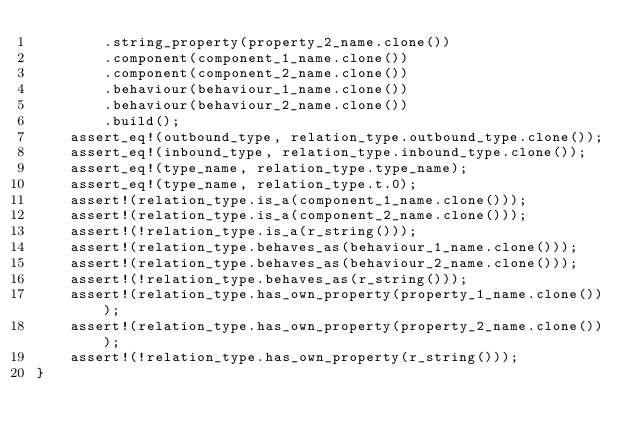<code> <loc_0><loc_0><loc_500><loc_500><_Rust_>        .string_property(property_2_name.clone())
        .component(component_1_name.clone())
        .component(component_2_name.clone())
        .behaviour(behaviour_1_name.clone())
        .behaviour(behaviour_2_name.clone())
        .build();
    assert_eq!(outbound_type, relation_type.outbound_type.clone());
    assert_eq!(inbound_type, relation_type.inbound_type.clone());
    assert_eq!(type_name, relation_type.type_name);
    assert_eq!(type_name, relation_type.t.0);
    assert!(relation_type.is_a(component_1_name.clone()));
    assert!(relation_type.is_a(component_2_name.clone()));
    assert!(!relation_type.is_a(r_string()));
    assert!(relation_type.behaves_as(behaviour_1_name.clone()));
    assert!(relation_type.behaves_as(behaviour_2_name.clone()));
    assert!(!relation_type.behaves_as(r_string()));
    assert!(relation_type.has_own_property(property_1_name.clone()));
    assert!(relation_type.has_own_property(property_2_name.clone()));
    assert!(!relation_type.has_own_property(r_string()));
}
</code> 